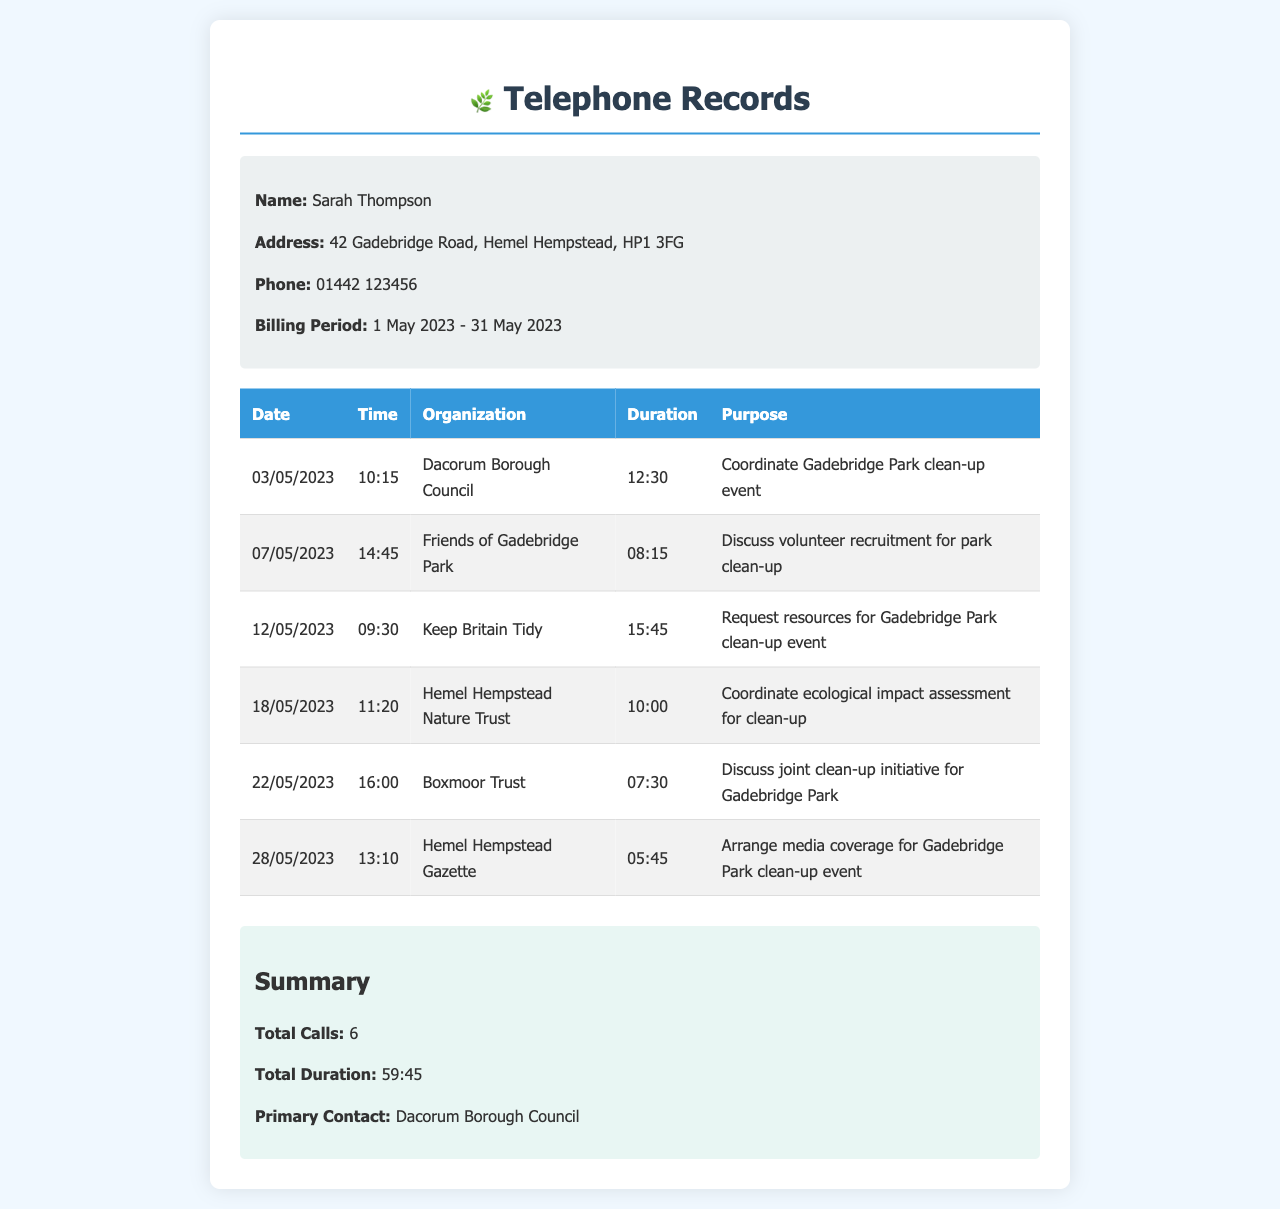What is the primary contact organization? The primary contact organization indicated in the summary section of the document is mentioned clearly.
Answer: Dacorum Borough Council How many total calls were made? In the summary section, the total number of calls is provided, indicating the total interactions during the billing period.
Answer: 6 What was the duration of the call with Keep Britain Tidy? The specific duration of the call with Keep Britain Tidy is recorded in the table, detailing the time spent on that call.
Answer: 15:45 Which date was the call to Boxmoor Trust made? The date for the call to Boxmoor Trust is listed in the table under the respective call details.
Answer: 22/05/2023 What was the purpose of the call to Friends of Gadebridge Park? Each call's purpose is detailed in the document, providing insights into the discussions that took place.
Answer: Discuss volunteer recruitment for park clean-up How long was the call made on 18/05/2023? The duration for the call on that specific date is noted in the table and represents the time taken on the call.
Answer: 10:00 What organization was contacted for media coverage? The organization responsible for arranging media coverage is mentioned explicitly in the table of calls.
Answer: Hemel Hempstead Gazette Which call had the shortest duration? By evaluating the provided durations, we identify which call lasted the least amount of time according to the document details.
Answer: 5:45 